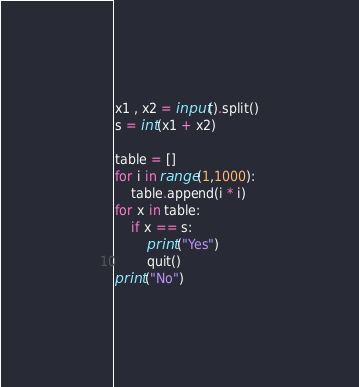Convert code to text. <code><loc_0><loc_0><loc_500><loc_500><_Python_>x1 , x2 = input().split()
s = int(x1 + x2)

table = []
for i in range(1,1000):
    table.append(i * i)
for x in table:
    if x == s:
        print("Yes")
        quit()
print("No")
</code> 